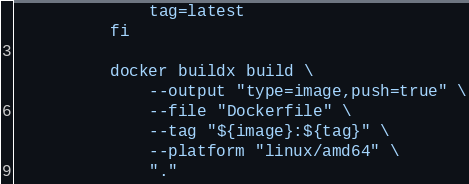Convert code to text. <code><loc_0><loc_0><loc_500><loc_500><_YAML_>              tag=latest
          fi

          docker buildx build \
              --output "type=image,push=true" \
              --file "Dockerfile" \
              --tag "${image}:${tag}" \
              --platform "linux/amd64" \
              "."
</code> 